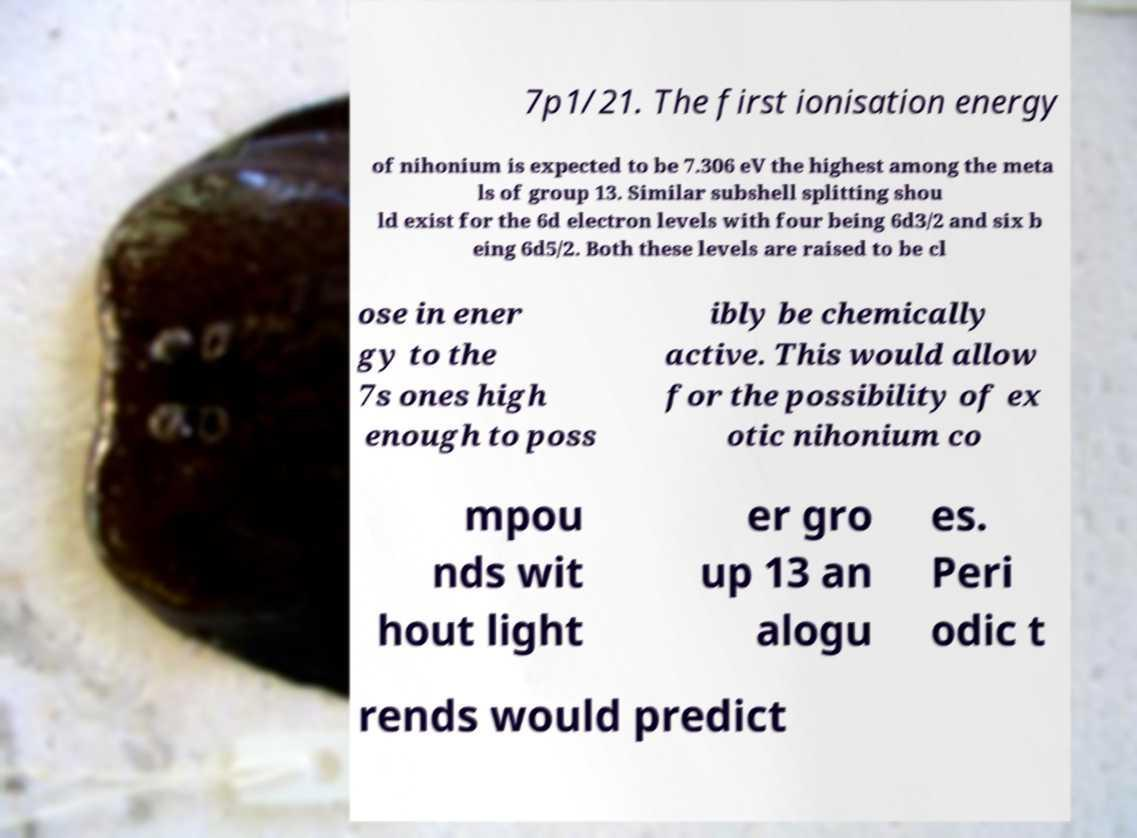Please read and relay the text visible in this image. What does it say? 7p1/21. The first ionisation energy of nihonium is expected to be 7.306 eV the highest among the meta ls of group 13. Similar subshell splitting shou ld exist for the 6d electron levels with four being 6d3/2 and six b eing 6d5/2. Both these levels are raised to be cl ose in ener gy to the 7s ones high enough to poss ibly be chemically active. This would allow for the possibility of ex otic nihonium co mpou nds wit hout light er gro up 13 an alogu es. Peri odic t rends would predict 